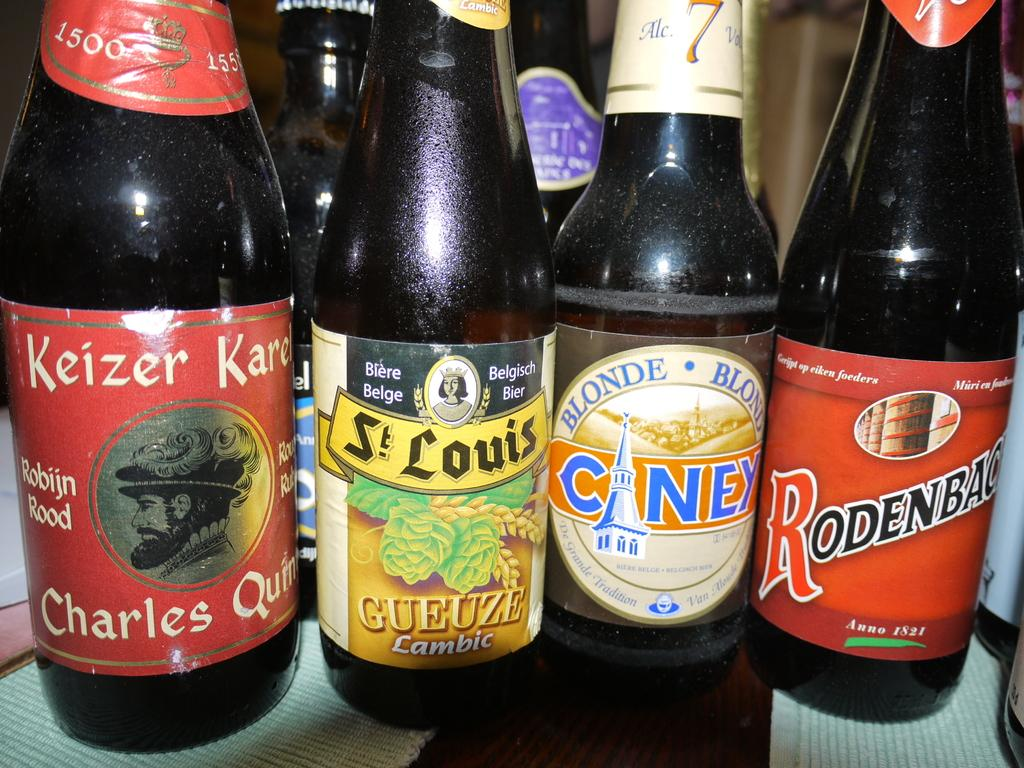<image>
Share a concise interpretation of the image provided. Four beer bottles with one that is a blonde ale 